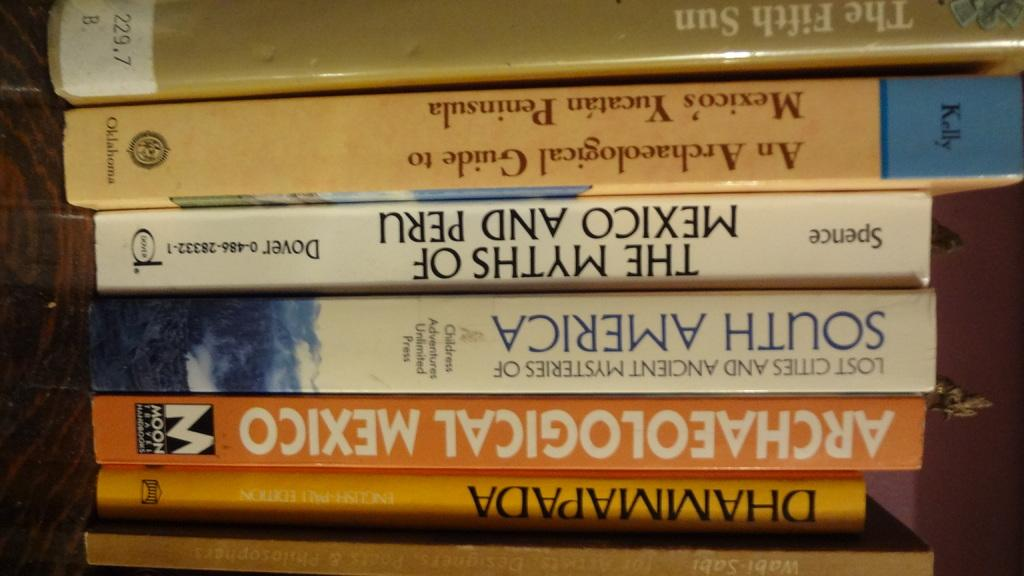<image>
Offer a succinct explanation of the picture presented. a book that reads The Myths of Mexico and Peru 